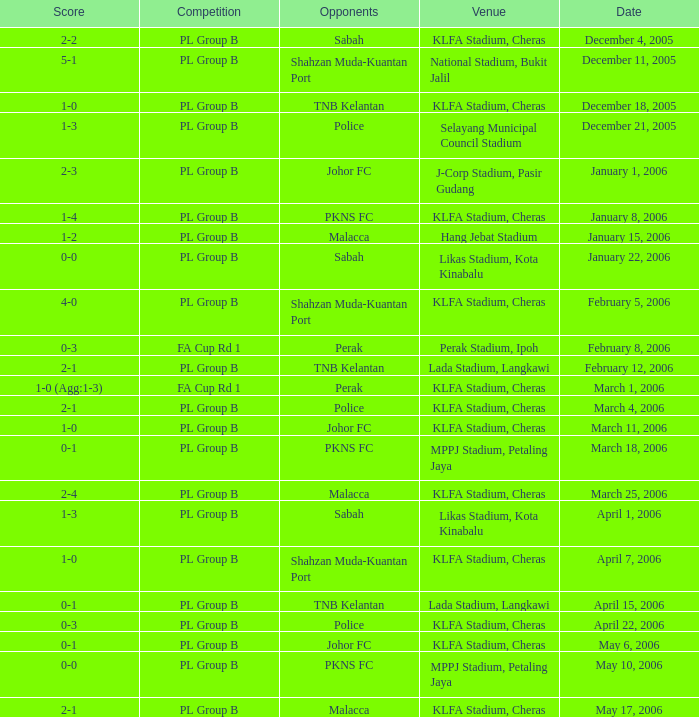Which Date has a Competition of pl group b, and Opponents of police, and a Venue of selayang municipal council stadium? December 21, 2005. 